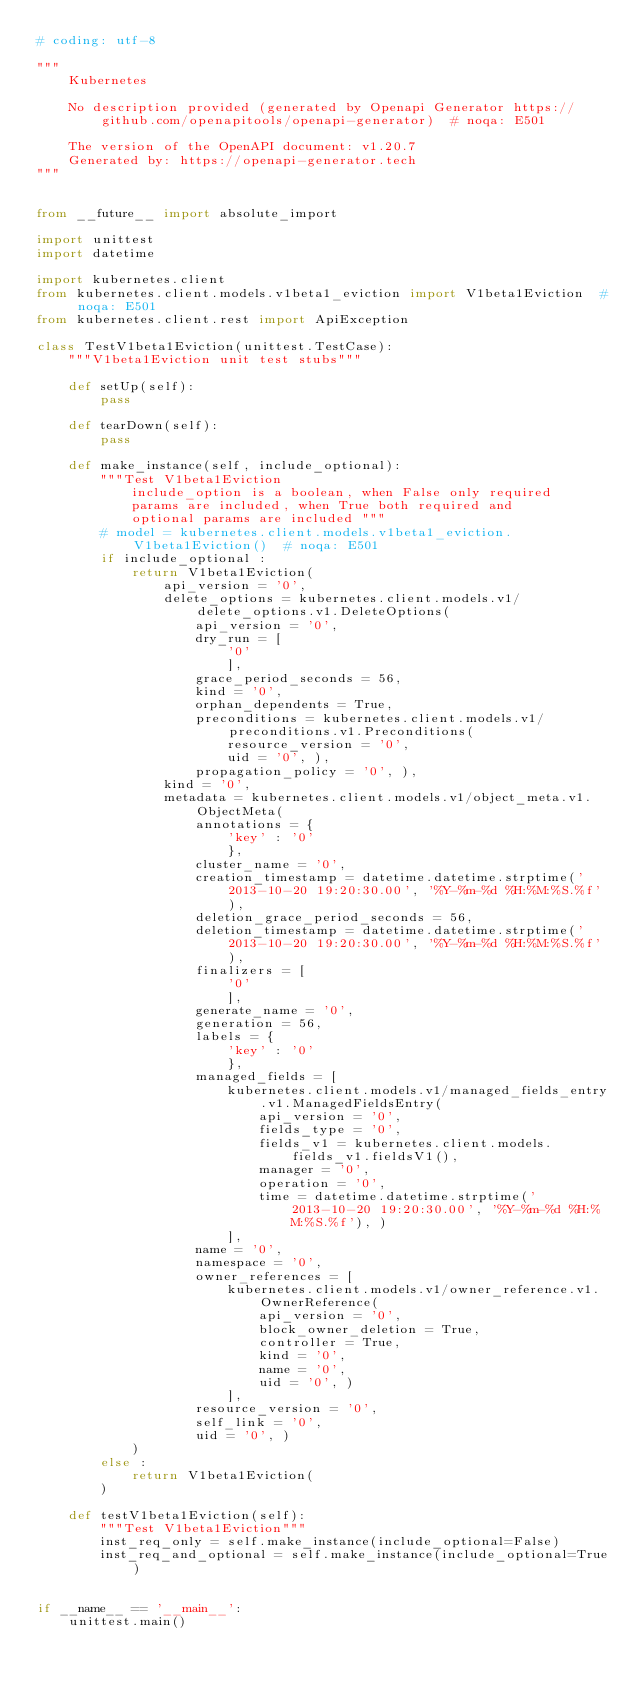Convert code to text. <code><loc_0><loc_0><loc_500><loc_500><_Python_># coding: utf-8

"""
    Kubernetes

    No description provided (generated by Openapi Generator https://github.com/openapitools/openapi-generator)  # noqa: E501

    The version of the OpenAPI document: v1.20.7
    Generated by: https://openapi-generator.tech
"""


from __future__ import absolute_import

import unittest
import datetime

import kubernetes.client
from kubernetes.client.models.v1beta1_eviction import V1beta1Eviction  # noqa: E501
from kubernetes.client.rest import ApiException

class TestV1beta1Eviction(unittest.TestCase):
    """V1beta1Eviction unit test stubs"""

    def setUp(self):
        pass

    def tearDown(self):
        pass

    def make_instance(self, include_optional):
        """Test V1beta1Eviction
            include_option is a boolean, when False only required
            params are included, when True both required and
            optional params are included """
        # model = kubernetes.client.models.v1beta1_eviction.V1beta1Eviction()  # noqa: E501
        if include_optional :
            return V1beta1Eviction(
                api_version = '0', 
                delete_options = kubernetes.client.models.v1/delete_options.v1.DeleteOptions(
                    api_version = '0', 
                    dry_run = [
                        '0'
                        ], 
                    grace_period_seconds = 56, 
                    kind = '0', 
                    orphan_dependents = True, 
                    preconditions = kubernetes.client.models.v1/preconditions.v1.Preconditions(
                        resource_version = '0', 
                        uid = '0', ), 
                    propagation_policy = '0', ), 
                kind = '0', 
                metadata = kubernetes.client.models.v1/object_meta.v1.ObjectMeta(
                    annotations = {
                        'key' : '0'
                        }, 
                    cluster_name = '0', 
                    creation_timestamp = datetime.datetime.strptime('2013-10-20 19:20:30.00', '%Y-%m-%d %H:%M:%S.%f'), 
                    deletion_grace_period_seconds = 56, 
                    deletion_timestamp = datetime.datetime.strptime('2013-10-20 19:20:30.00', '%Y-%m-%d %H:%M:%S.%f'), 
                    finalizers = [
                        '0'
                        ], 
                    generate_name = '0', 
                    generation = 56, 
                    labels = {
                        'key' : '0'
                        }, 
                    managed_fields = [
                        kubernetes.client.models.v1/managed_fields_entry.v1.ManagedFieldsEntry(
                            api_version = '0', 
                            fields_type = '0', 
                            fields_v1 = kubernetes.client.models.fields_v1.fieldsV1(), 
                            manager = '0', 
                            operation = '0', 
                            time = datetime.datetime.strptime('2013-10-20 19:20:30.00', '%Y-%m-%d %H:%M:%S.%f'), )
                        ], 
                    name = '0', 
                    namespace = '0', 
                    owner_references = [
                        kubernetes.client.models.v1/owner_reference.v1.OwnerReference(
                            api_version = '0', 
                            block_owner_deletion = True, 
                            controller = True, 
                            kind = '0', 
                            name = '0', 
                            uid = '0', )
                        ], 
                    resource_version = '0', 
                    self_link = '0', 
                    uid = '0', )
            )
        else :
            return V1beta1Eviction(
        )

    def testV1beta1Eviction(self):
        """Test V1beta1Eviction"""
        inst_req_only = self.make_instance(include_optional=False)
        inst_req_and_optional = self.make_instance(include_optional=True)


if __name__ == '__main__':
    unittest.main()
</code> 